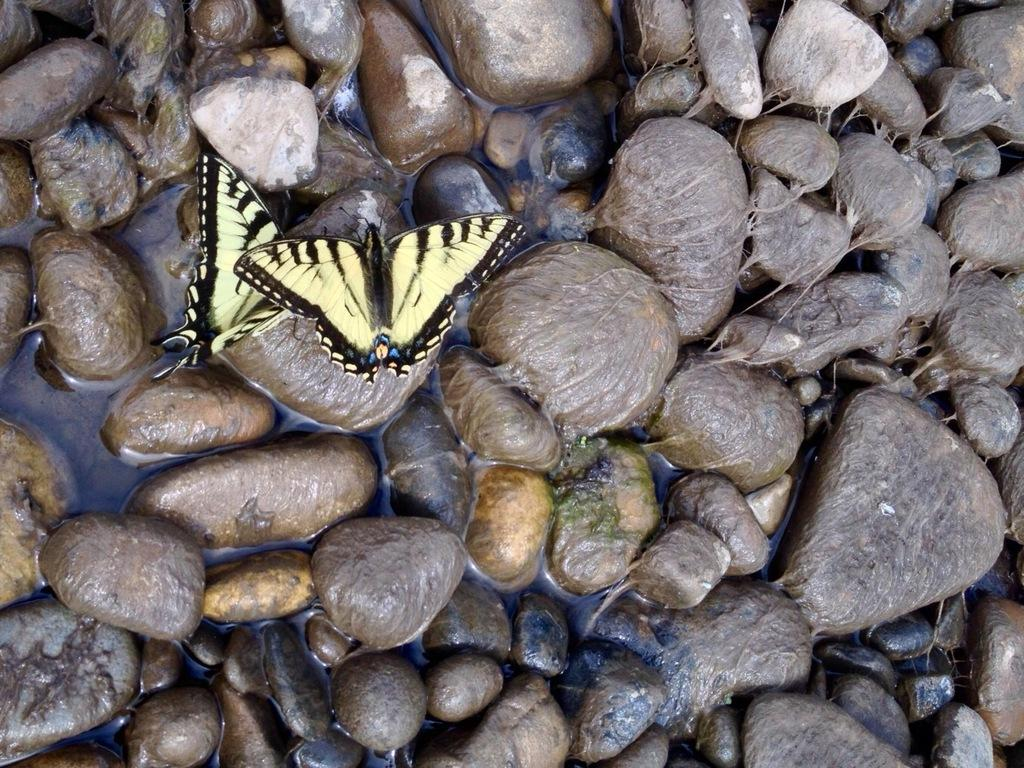What type of animals can be seen in the image? There are butterflies in the image. What other objects or elements can be seen in the image? There are pebbles and water visible in the image. What type of lumber is being used to build the pig pen in the image? There is no mention of lumber or pigs in the provided facts. The image only contains butterflies, pebbles, and water. Therefore, we cannot answer any questions related to lumber or pigs. Absurd Question/Answer: What type of pollution can be seen in the image? There is no pollution visible in the image. The image only contains butterflies, pebbles, and water. 